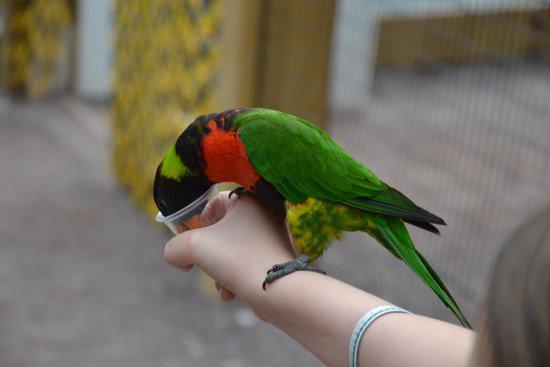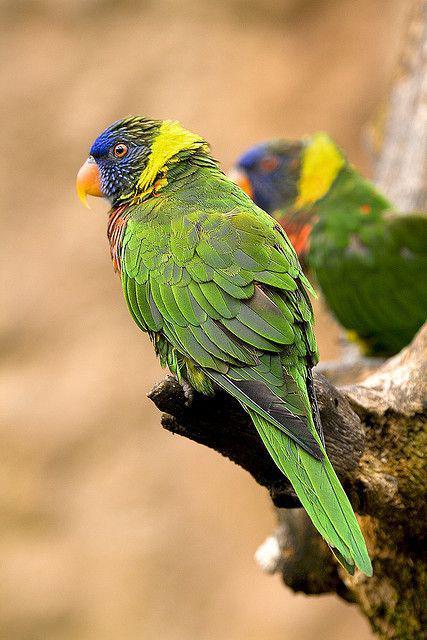The first image is the image on the left, the second image is the image on the right. For the images displayed, is the sentence "In total, the images contain no more than three parrots." factually correct? Answer yes or no. Yes. The first image is the image on the left, the second image is the image on the right. For the images shown, is this caption "There are no more than three birds" true? Answer yes or no. Yes. 